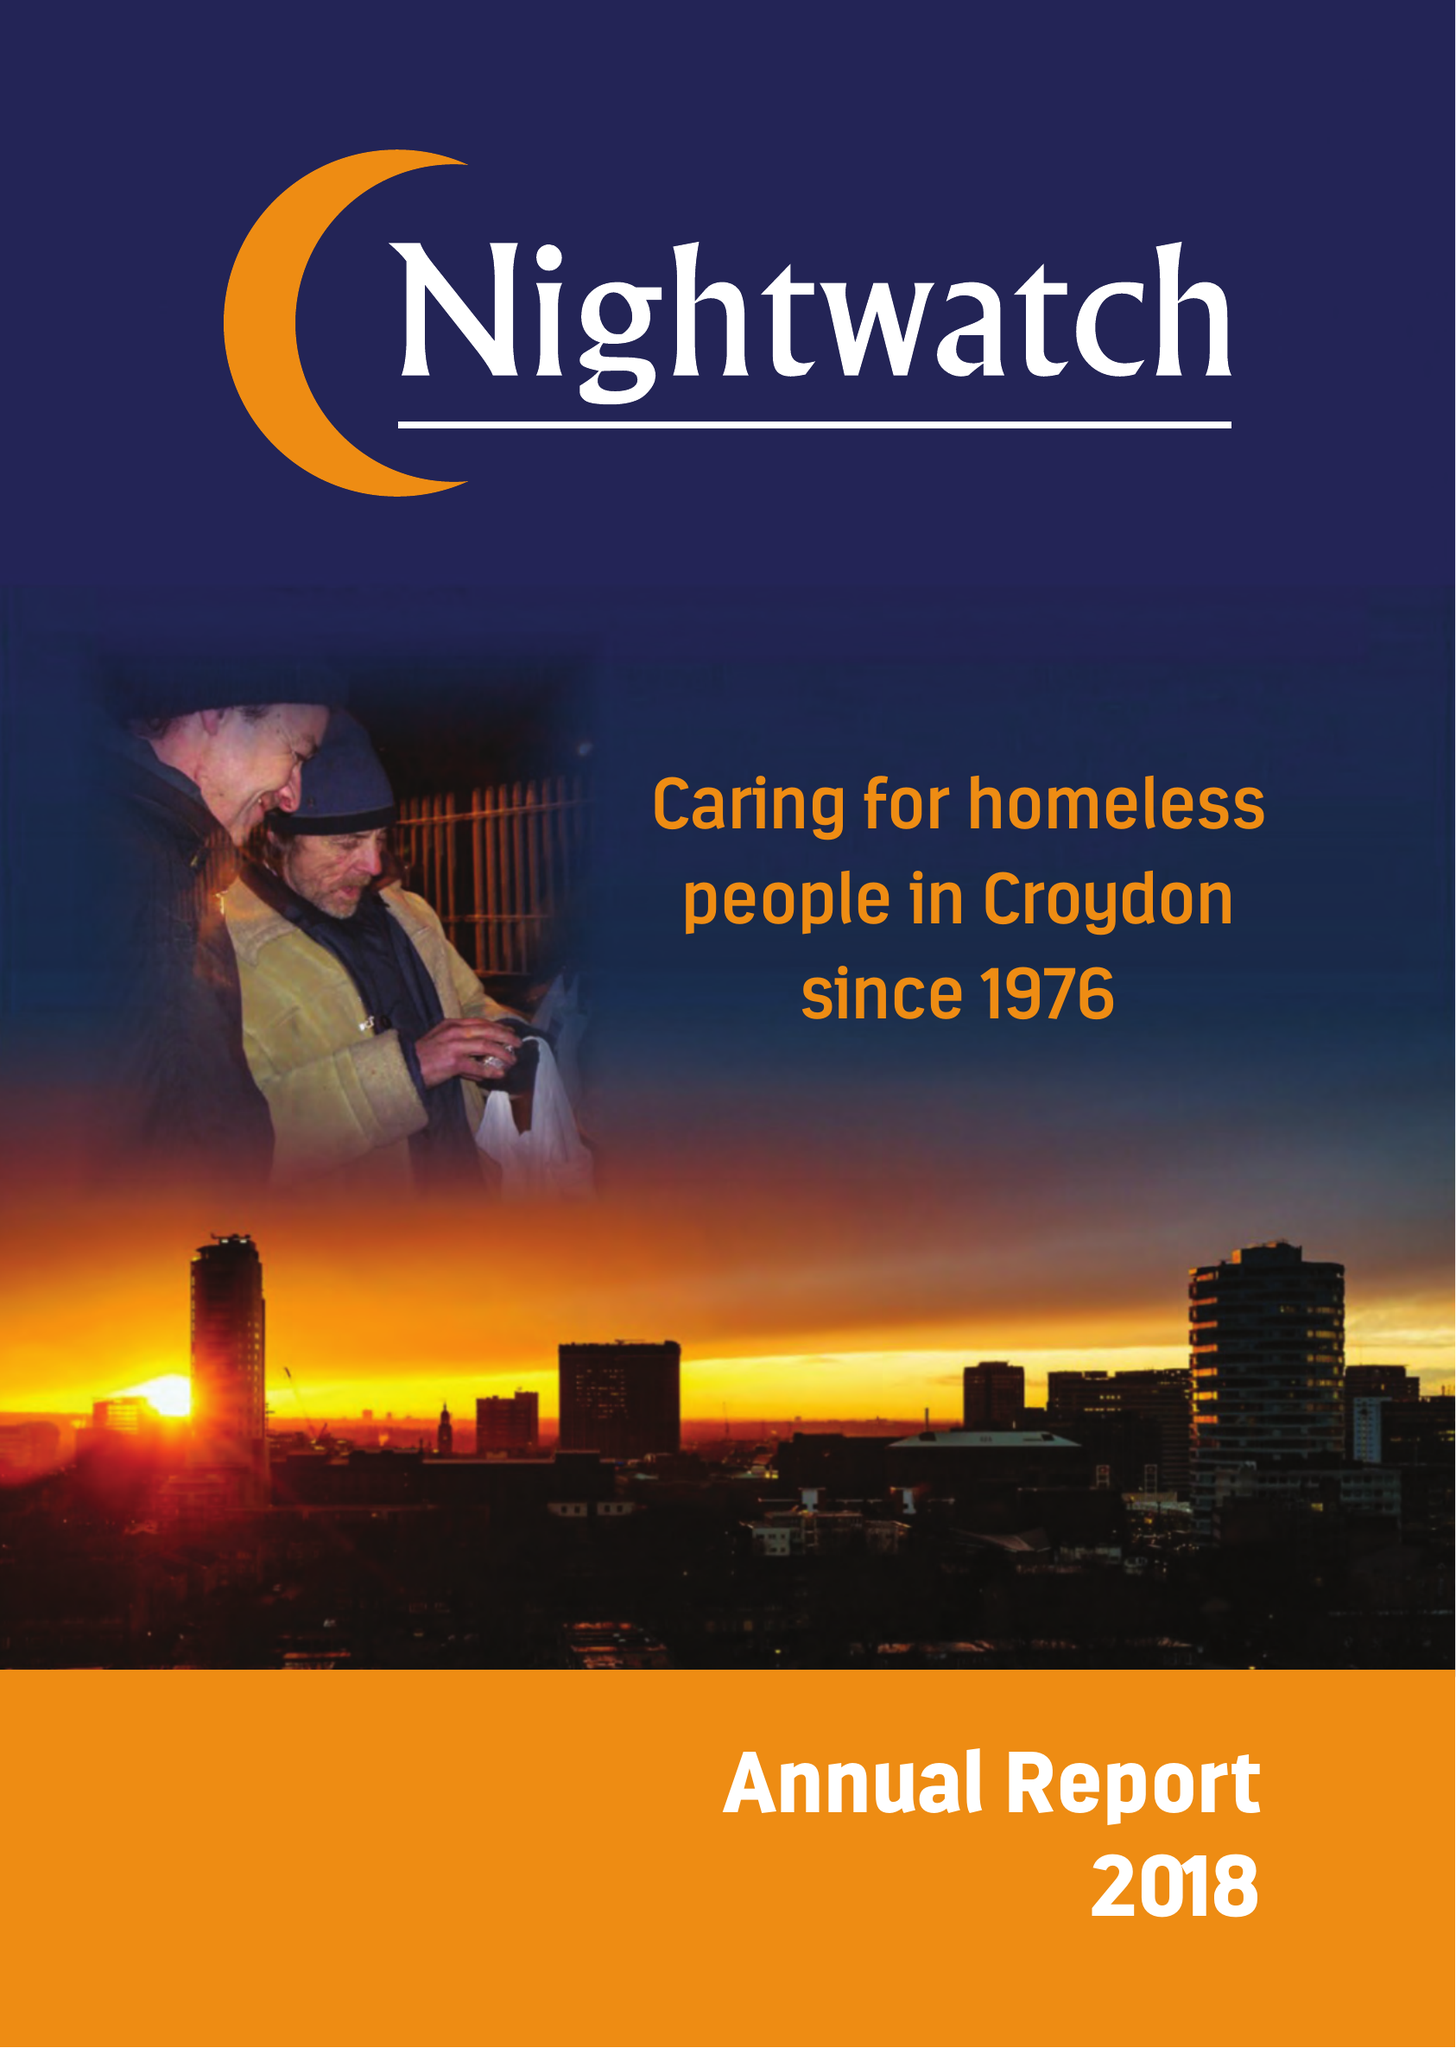What is the value for the spending_annually_in_british_pounds?
Answer the question using a single word or phrase. 29440.00 